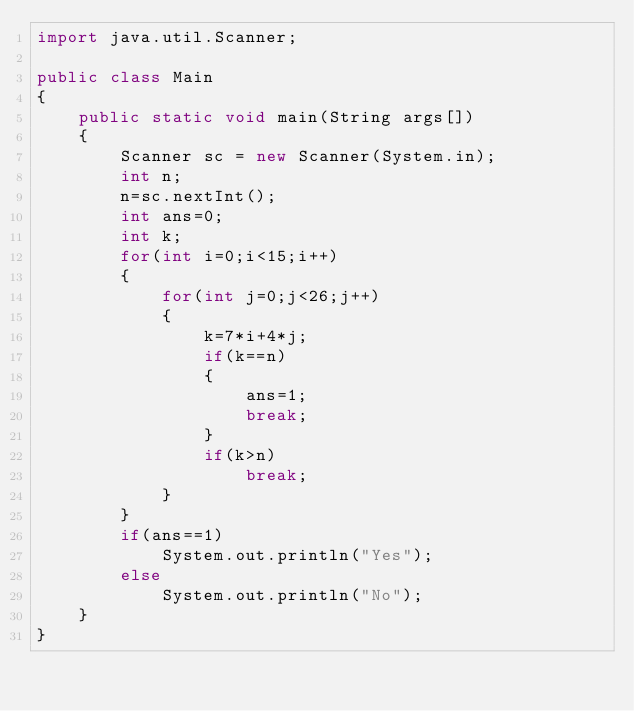<code> <loc_0><loc_0><loc_500><loc_500><_Java_>import java.util.Scanner;

public class Main 
{
	public static void main(String args[])
	{
		Scanner sc = new Scanner(System.in);
		int n;
		n=sc.nextInt();
		int ans=0;
		int k;
		for(int i=0;i<15;i++)
		{
			for(int j=0;j<26;j++)
			{
				k=7*i+4*j;
				if(k==n)
				{
					ans=1;
					break;
				}
				if(k>n)
					break;
			}
		}
		if(ans==1)
			System.out.println("Yes");
		else
			System.out.println("No");
	}
}
</code> 